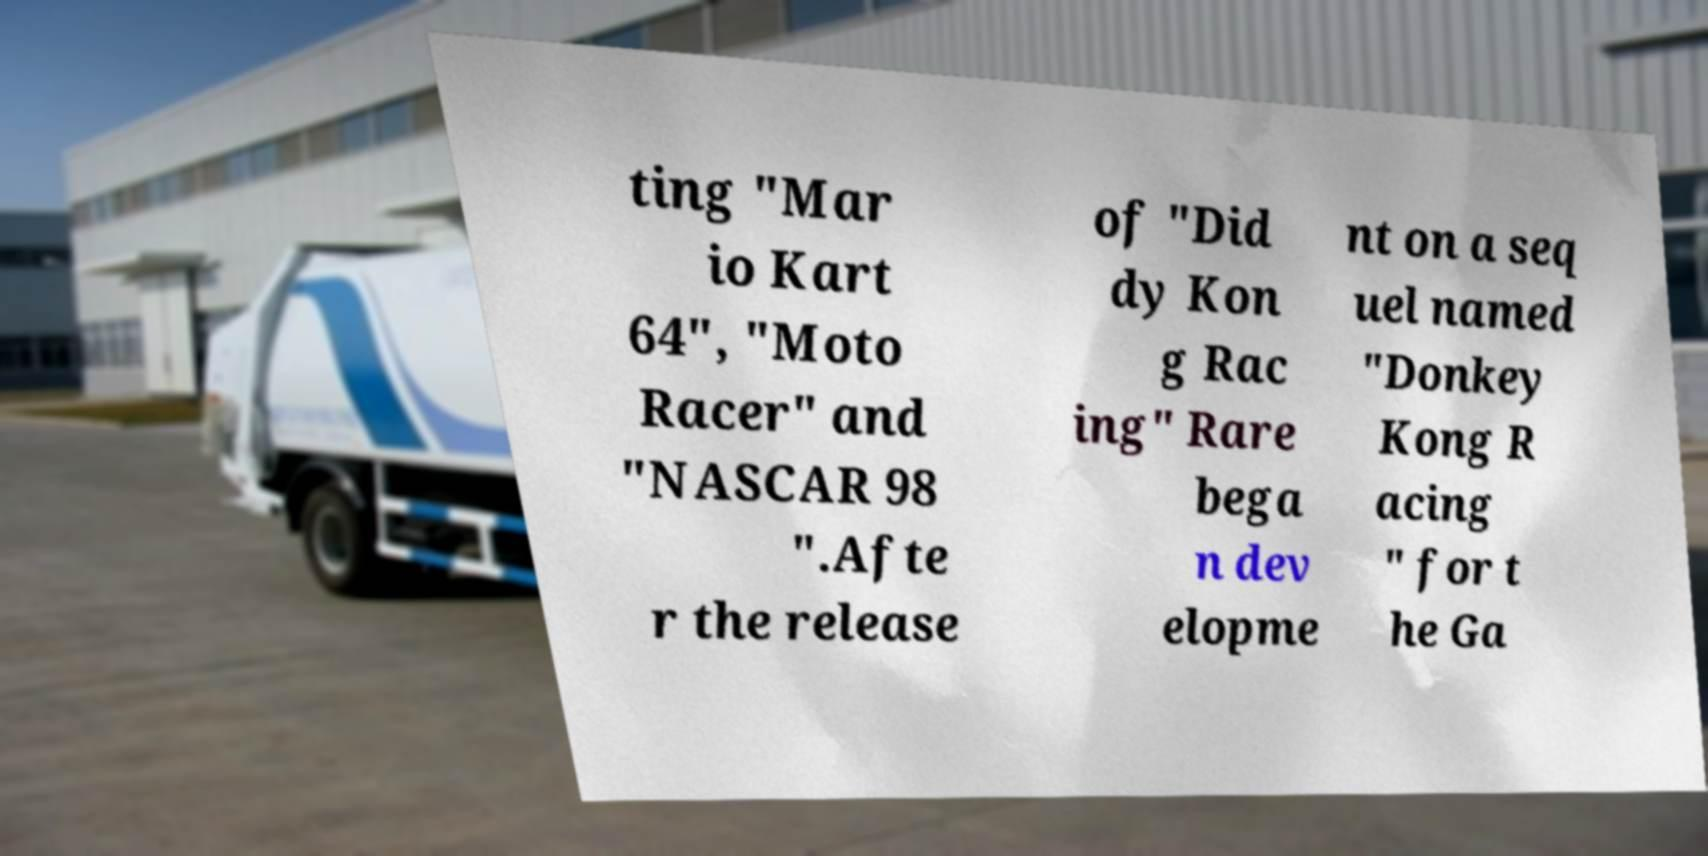Can you read and provide the text displayed in the image?This photo seems to have some interesting text. Can you extract and type it out for me? ting "Mar io Kart 64", "Moto Racer" and "NASCAR 98 ".Afte r the release of "Did dy Kon g Rac ing" Rare bega n dev elopme nt on a seq uel named "Donkey Kong R acing " for t he Ga 